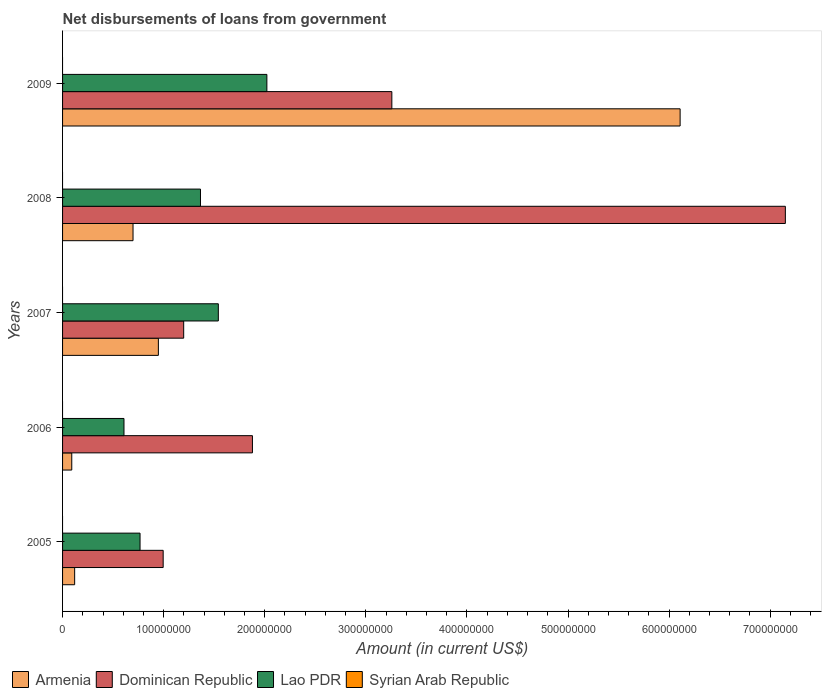How many different coloured bars are there?
Provide a short and direct response. 3. Are the number of bars per tick equal to the number of legend labels?
Provide a succinct answer. No. Are the number of bars on each tick of the Y-axis equal?
Make the answer very short. Yes. How many bars are there on the 3rd tick from the top?
Your answer should be compact. 3. What is the amount of loan disbursed from government in Armenia in 2006?
Offer a very short reply. 9.10e+06. Across all years, what is the maximum amount of loan disbursed from government in Dominican Republic?
Provide a succinct answer. 7.15e+08. Across all years, what is the minimum amount of loan disbursed from government in Dominican Republic?
Offer a terse response. 9.95e+07. What is the total amount of loan disbursed from government in Armenia in the graph?
Your response must be concise. 7.96e+08. What is the difference between the amount of loan disbursed from government in Lao PDR in 2006 and that in 2009?
Keep it short and to the point. -1.41e+08. What is the difference between the amount of loan disbursed from government in Dominican Republic in 2006 and the amount of loan disbursed from government in Syrian Arab Republic in 2008?
Provide a short and direct response. 1.88e+08. What is the average amount of loan disbursed from government in Armenia per year?
Give a very brief answer. 1.59e+08. In the year 2008, what is the difference between the amount of loan disbursed from government in Lao PDR and amount of loan disbursed from government in Armenia?
Your answer should be very brief. 6.67e+07. What is the ratio of the amount of loan disbursed from government in Lao PDR in 2006 to that in 2009?
Offer a terse response. 0.3. Is the amount of loan disbursed from government in Lao PDR in 2007 less than that in 2008?
Ensure brevity in your answer.  No. What is the difference between the highest and the second highest amount of loan disbursed from government in Dominican Republic?
Offer a very short reply. 3.89e+08. What is the difference between the highest and the lowest amount of loan disbursed from government in Dominican Republic?
Offer a very short reply. 6.15e+08. Is it the case that in every year, the sum of the amount of loan disbursed from government in Armenia and amount of loan disbursed from government in Syrian Arab Republic is greater than the sum of amount of loan disbursed from government in Lao PDR and amount of loan disbursed from government in Dominican Republic?
Your answer should be compact. No. How many bars are there?
Your answer should be compact. 15. How many years are there in the graph?
Make the answer very short. 5. Does the graph contain any zero values?
Provide a short and direct response. Yes. Does the graph contain grids?
Your answer should be compact. No. How are the legend labels stacked?
Your answer should be very brief. Horizontal. What is the title of the graph?
Offer a terse response. Net disbursements of loans from government. Does "Middle East & North Africa (all income levels)" appear as one of the legend labels in the graph?
Your response must be concise. No. What is the label or title of the Y-axis?
Ensure brevity in your answer.  Years. What is the Amount (in current US$) in Armenia in 2005?
Your answer should be very brief. 1.20e+07. What is the Amount (in current US$) of Dominican Republic in 2005?
Make the answer very short. 9.95e+07. What is the Amount (in current US$) of Lao PDR in 2005?
Provide a short and direct response. 7.66e+07. What is the Amount (in current US$) of Syrian Arab Republic in 2005?
Offer a very short reply. 0. What is the Amount (in current US$) of Armenia in 2006?
Offer a terse response. 9.10e+06. What is the Amount (in current US$) in Dominican Republic in 2006?
Your answer should be very brief. 1.88e+08. What is the Amount (in current US$) in Lao PDR in 2006?
Provide a short and direct response. 6.08e+07. What is the Amount (in current US$) of Armenia in 2007?
Your answer should be very brief. 9.48e+07. What is the Amount (in current US$) in Dominican Republic in 2007?
Keep it short and to the point. 1.20e+08. What is the Amount (in current US$) of Lao PDR in 2007?
Your answer should be very brief. 1.54e+08. What is the Amount (in current US$) of Armenia in 2008?
Offer a very short reply. 6.97e+07. What is the Amount (in current US$) of Dominican Republic in 2008?
Offer a terse response. 7.15e+08. What is the Amount (in current US$) of Lao PDR in 2008?
Offer a very short reply. 1.36e+08. What is the Amount (in current US$) in Armenia in 2009?
Offer a terse response. 6.11e+08. What is the Amount (in current US$) of Dominican Republic in 2009?
Keep it short and to the point. 3.26e+08. What is the Amount (in current US$) of Lao PDR in 2009?
Keep it short and to the point. 2.02e+08. Across all years, what is the maximum Amount (in current US$) of Armenia?
Provide a short and direct response. 6.11e+08. Across all years, what is the maximum Amount (in current US$) of Dominican Republic?
Make the answer very short. 7.15e+08. Across all years, what is the maximum Amount (in current US$) in Lao PDR?
Provide a succinct answer. 2.02e+08. Across all years, what is the minimum Amount (in current US$) in Armenia?
Your response must be concise. 9.10e+06. Across all years, what is the minimum Amount (in current US$) in Dominican Republic?
Provide a short and direct response. 9.95e+07. Across all years, what is the minimum Amount (in current US$) in Lao PDR?
Your answer should be compact. 6.08e+07. What is the total Amount (in current US$) of Armenia in the graph?
Offer a very short reply. 7.96e+08. What is the total Amount (in current US$) of Dominican Republic in the graph?
Make the answer very short. 1.45e+09. What is the total Amount (in current US$) of Lao PDR in the graph?
Offer a terse response. 6.30e+08. What is the difference between the Amount (in current US$) of Armenia in 2005 and that in 2006?
Your response must be concise. 2.87e+06. What is the difference between the Amount (in current US$) of Dominican Republic in 2005 and that in 2006?
Your answer should be very brief. -8.83e+07. What is the difference between the Amount (in current US$) of Lao PDR in 2005 and that in 2006?
Offer a very short reply. 1.59e+07. What is the difference between the Amount (in current US$) in Armenia in 2005 and that in 2007?
Provide a short and direct response. -8.28e+07. What is the difference between the Amount (in current US$) of Dominican Republic in 2005 and that in 2007?
Give a very brief answer. -2.03e+07. What is the difference between the Amount (in current US$) of Lao PDR in 2005 and that in 2007?
Your answer should be very brief. -7.74e+07. What is the difference between the Amount (in current US$) in Armenia in 2005 and that in 2008?
Offer a terse response. -5.77e+07. What is the difference between the Amount (in current US$) of Dominican Republic in 2005 and that in 2008?
Provide a succinct answer. -6.15e+08. What is the difference between the Amount (in current US$) in Lao PDR in 2005 and that in 2008?
Your answer should be very brief. -5.98e+07. What is the difference between the Amount (in current US$) in Armenia in 2005 and that in 2009?
Provide a succinct answer. -5.99e+08. What is the difference between the Amount (in current US$) of Dominican Republic in 2005 and that in 2009?
Your answer should be very brief. -2.26e+08. What is the difference between the Amount (in current US$) in Lao PDR in 2005 and that in 2009?
Offer a terse response. -1.25e+08. What is the difference between the Amount (in current US$) of Armenia in 2006 and that in 2007?
Provide a succinct answer. -8.57e+07. What is the difference between the Amount (in current US$) in Dominican Republic in 2006 and that in 2007?
Provide a succinct answer. 6.80e+07. What is the difference between the Amount (in current US$) in Lao PDR in 2006 and that in 2007?
Offer a terse response. -9.33e+07. What is the difference between the Amount (in current US$) in Armenia in 2006 and that in 2008?
Provide a short and direct response. -6.06e+07. What is the difference between the Amount (in current US$) in Dominican Republic in 2006 and that in 2008?
Your answer should be very brief. -5.27e+08. What is the difference between the Amount (in current US$) in Lao PDR in 2006 and that in 2008?
Keep it short and to the point. -7.57e+07. What is the difference between the Amount (in current US$) in Armenia in 2006 and that in 2009?
Your answer should be very brief. -6.02e+08. What is the difference between the Amount (in current US$) of Dominican Republic in 2006 and that in 2009?
Give a very brief answer. -1.38e+08. What is the difference between the Amount (in current US$) of Lao PDR in 2006 and that in 2009?
Your answer should be compact. -1.41e+08. What is the difference between the Amount (in current US$) in Armenia in 2007 and that in 2008?
Provide a succinct answer. 2.51e+07. What is the difference between the Amount (in current US$) in Dominican Republic in 2007 and that in 2008?
Your answer should be very brief. -5.95e+08. What is the difference between the Amount (in current US$) in Lao PDR in 2007 and that in 2008?
Provide a succinct answer. 1.76e+07. What is the difference between the Amount (in current US$) in Armenia in 2007 and that in 2009?
Your answer should be compact. -5.16e+08. What is the difference between the Amount (in current US$) of Dominican Republic in 2007 and that in 2009?
Your answer should be compact. -2.06e+08. What is the difference between the Amount (in current US$) of Lao PDR in 2007 and that in 2009?
Your response must be concise. -4.80e+07. What is the difference between the Amount (in current US$) in Armenia in 2008 and that in 2009?
Your response must be concise. -5.41e+08. What is the difference between the Amount (in current US$) in Dominican Republic in 2008 and that in 2009?
Your answer should be compact. 3.89e+08. What is the difference between the Amount (in current US$) in Lao PDR in 2008 and that in 2009?
Ensure brevity in your answer.  -6.57e+07. What is the difference between the Amount (in current US$) in Armenia in 2005 and the Amount (in current US$) in Dominican Republic in 2006?
Make the answer very short. -1.76e+08. What is the difference between the Amount (in current US$) in Armenia in 2005 and the Amount (in current US$) in Lao PDR in 2006?
Give a very brief answer. -4.88e+07. What is the difference between the Amount (in current US$) in Dominican Republic in 2005 and the Amount (in current US$) in Lao PDR in 2006?
Your answer should be very brief. 3.88e+07. What is the difference between the Amount (in current US$) of Armenia in 2005 and the Amount (in current US$) of Dominican Republic in 2007?
Offer a terse response. -1.08e+08. What is the difference between the Amount (in current US$) in Armenia in 2005 and the Amount (in current US$) in Lao PDR in 2007?
Offer a very short reply. -1.42e+08. What is the difference between the Amount (in current US$) of Dominican Republic in 2005 and the Amount (in current US$) of Lao PDR in 2007?
Your answer should be compact. -5.46e+07. What is the difference between the Amount (in current US$) of Armenia in 2005 and the Amount (in current US$) of Dominican Republic in 2008?
Offer a very short reply. -7.03e+08. What is the difference between the Amount (in current US$) of Armenia in 2005 and the Amount (in current US$) of Lao PDR in 2008?
Your answer should be compact. -1.24e+08. What is the difference between the Amount (in current US$) in Dominican Republic in 2005 and the Amount (in current US$) in Lao PDR in 2008?
Make the answer very short. -3.69e+07. What is the difference between the Amount (in current US$) in Armenia in 2005 and the Amount (in current US$) in Dominican Republic in 2009?
Ensure brevity in your answer.  -3.14e+08. What is the difference between the Amount (in current US$) in Armenia in 2005 and the Amount (in current US$) in Lao PDR in 2009?
Keep it short and to the point. -1.90e+08. What is the difference between the Amount (in current US$) of Dominican Republic in 2005 and the Amount (in current US$) of Lao PDR in 2009?
Make the answer very short. -1.03e+08. What is the difference between the Amount (in current US$) in Armenia in 2006 and the Amount (in current US$) in Dominican Republic in 2007?
Keep it short and to the point. -1.11e+08. What is the difference between the Amount (in current US$) in Armenia in 2006 and the Amount (in current US$) in Lao PDR in 2007?
Your answer should be very brief. -1.45e+08. What is the difference between the Amount (in current US$) in Dominican Republic in 2006 and the Amount (in current US$) in Lao PDR in 2007?
Ensure brevity in your answer.  3.37e+07. What is the difference between the Amount (in current US$) of Armenia in 2006 and the Amount (in current US$) of Dominican Republic in 2008?
Your answer should be compact. -7.06e+08. What is the difference between the Amount (in current US$) in Armenia in 2006 and the Amount (in current US$) in Lao PDR in 2008?
Provide a succinct answer. -1.27e+08. What is the difference between the Amount (in current US$) in Dominican Republic in 2006 and the Amount (in current US$) in Lao PDR in 2008?
Give a very brief answer. 5.14e+07. What is the difference between the Amount (in current US$) of Armenia in 2006 and the Amount (in current US$) of Dominican Republic in 2009?
Your answer should be compact. -3.17e+08. What is the difference between the Amount (in current US$) in Armenia in 2006 and the Amount (in current US$) in Lao PDR in 2009?
Offer a very short reply. -1.93e+08. What is the difference between the Amount (in current US$) in Dominican Republic in 2006 and the Amount (in current US$) in Lao PDR in 2009?
Provide a short and direct response. -1.43e+07. What is the difference between the Amount (in current US$) of Armenia in 2007 and the Amount (in current US$) of Dominican Republic in 2008?
Your answer should be very brief. -6.20e+08. What is the difference between the Amount (in current US$) of Armenia in 2007 and the Amount (in current US$) of Lao PDR in 2008?
Offer a very short reply. -4.16e+07. What is the difference between the Amount (in current US$) in Dominican Republic in 2007 and the Amount (in current US$) in Lao PDR in 2008?
Offer a terse response. -1.66e+07. What is the difference between the Amount (in current US$) in Armenia in 2007 and the Amount (in current US$) in Dominican Republic in 2009?
Offer a terse response. -2.31e+08. What is the difference between the Amount (in current US$) in Armenia in 2007 and the Amount (in current US$) in Lao PDR in 2009?
Your response must be concise. -1.07e+08. What is the difference between the Amount (in current US$) in Dominican Republic in 2007 and the Amount (in current US$) in Lao PDR in 2009?
Offer a terse response. -8.23e+07. What is the difference between the Amount (in current US$) in Armenia in 2008 and the Amount (in current US$) in Dominican Republic in 2009?
Offer a terse response. -2.56e+08. What is the difference between the Amount (in current US$) in Armenia in 2008 and the Amount (in current US$) in Lao PDR in 2009?
Your response must be concise. -1.32e+08. What is the difference between the Amount (in current US$) in Dominican Republic in 2008 and the Amount (in current US$) in Lao PDR in 2009?
Your answer should be compact. 5.13e+08. What is the average Amount (in current US$) in Armenia per year?
Ensure brevity in your answer.  1.59e+08. What is the average Amount (in current US$) in Dominican Republic per year?
Offer a very short reply. 2.90e+08. What is the average Amount (in current US$) in Lao PDR per year?
Give a very brief answer. 1.26e+08. In the year 2005, what is the difference between the Amount (in current US$) in Armenia and Amount (in current US$) in Dominican Republic?
Your answer should be compact. -8.76e+07. In the year 2005, what is the difference between the Amount (in current US$) in Armenia and Amount (in current US$) in Lao PDR?
Ensure brevity in your answer.  -6.47e+07. In the year 2005, what is the difference between the Amount (in current US$) in Dominican Republic and Amount (in current US$) in Lao PDR?
Ensure brevity in your answer.  2.29e+07. In the year 2006, what is the difference between the Amount (in current US$) in Armenia and Amount (in current US$) in Dominican Republic?
Provide a succinct answer. -1.79e+08. In the year 2006, what is the difference between the Amount (in current US$) in Armenia and Amount (in current US$) in Lao PDR?
Your response must be concise. -5.17e+07. In the year 2006, what is the difference between the Amount (in current US$) of Dominican Republic and Amount (in current US$) of Lao PDR?
Your answer should be compact. 1.27e+08. In the year 2007, what is the difference between the Amount (in current US$) of Armenia and Amount (in current US$) of Dominican Republic?
Provide a short and direct response. -2.50e+07. In the year 2007, what is the difference between the Amount (in current US$) of Armenia and Amount (in current US$) of Lao PDR?
Provide a short and direct response. -5.93e+07. In the year 2007, what is the difference between the Amount (in current US$) in Dominican Republic and Amount (in current US$) in Lao PDR?
Make the answer very short. -3.43e+07. In the year 2008, what is the difference between the Amount (in current US$) in Armenia and Amount (in current US$) in Dominican Republic?
Your answer should be very brief. -6.45e+08. In the year 2008, what is the difference between the Amount (in current US$) of Armenia and Amount (in current US$) of Lao PDR?
Your response must be concise. -6.67e+07. In the year 2008, what is the difference between the Amount (in current US$) of Dominican Republic and Amount (in current US$) of Lao PDR?
Your answer should be compact. 5.79e+08. In the year 2009, what is the difference between the Amount (in current US$) of Armenia and Amount (in current US$) of Dominican Republic?
Offer a very short reply. 2.85e+08. In the year 2009, what is the difference between the Amount (in current US$) of Armenia and Amount (in current US$) of Lao PDR?
Your response must be concise. 4.09e+08. In the year 2009, what is the difference between the Amount (in current US$) of Dominican Republic and Amount (in current US$) of Lao PDR?
Keep it short and to the point. 1.24e+08. What is the ratio of the Amount (in current US$) in Armenia in 2005 to that in 2006?
Ensure brevity in your answer.  1.32. What is the ratio of the Amount (in current US$) in Dominican Republic in 2005 to that in 2006?
Your answer should be compact. 0.53. What is the ratio of the Amount (in current US$) in Lao PDR in 2005 to that in 2006?
Ensure brevity in your answer.  1.26. What is the ratio of the Amount (in current US$) in Armenia in 2005 to that in 2007?
Offer a terse response. 0.13. What is the ratio of the Amount (in current US$) in Dominican Republic in 2005 to that in 2007?
Provide a short and direct response. 0.83. What is the ratio of the Amount (in current US$) of Lao PDR in 2005 to that in 2007?
Ensure brevity in your answer.  0.5. What is the ratio of the Amount (in current US$) of Armenia in 2005 to that in 2008?
Your response must be concise. 0.17. What is the ratio of the Amount (in current US$) in Dominican Republic in 2005 to that in 2008?
Your answer should be very brief. 0.14. What is the ratio of the Amount (in current US$) in Lao PDR in 2005 to that in 2008?
Your answer should be very brief. 0.56. What is the ratio of the Amount (in current US$) in Armenia in 2005 to that in 2009?
Make the answer very short. 0.02. What is the ratio of the Amount (in current US$) of Dominican Republic in 2005 to that in 2009?
Offer a terse response. 0.31. What is the ratio of the Amount (in current US$) of Lao PDR in 2005 to that in 2009?
Your response must be concise. 0.38. What is the ratio of the Amount (in current US$) in Armenia in 2006 to that in 2007?
Provide a short and direct response. 0.1. What is the ratio of the Amount (in current US$) in Dominican Republic in 2006 to that in 2007?
Your answer should be compact. 1.57. What is the ratio of the Amount (in current US$) of Lao PDR in 2006 to that in 2007?
Make the answer very short. 0.39. What is the ratio of the Amount (in current US$) of Armenia in 2006 to that in 2008?
Your answer should be compact. 0.13. What is the ratio of the Amount (in current US$) in Dominican Republic in 2006 to that in 2008?
Give a very brief answer. 0.26. What is the ratio of the Amount (in current US$) in Lao PDR in 2006 to that in 2008?
Give a very brief answer. 0.45. What is the ratio of the Amount (in current US$) in Armenia in 2006 to that in 2009?
Your response must be concise. 0.01. What is the ratio of the Amount (in current US$) in Dominican Republic in 2006 to that in 2009?
Your answer should be very brief. 0.58. What is the ratio of the Amount (in current US$) in Lao PDR in 2006 to that in 2009?
Ensure brevity in your answer.  0.3. What is the ratio of the Amount (in current US$) of Armenia in 2007 to that in 2008?
Provide a short and direct response. 1.36. What is the ratio of the Amount (in current US$) in Dominican Republic in 2007 to that in 2008?
Your response must be concise. 0.17. What is the ratio of the Amount (in current US$) in Lao PDR in 2007 to that in 2008?
Your response must be concise. 1.13. What is the ratio of the Amount (in current US$) in Armenia in 2007 to that in 2009?
Give a very brief answer. 0.16. What is the ratio of the Amount (in current US$) of Dominican Republic in 2007 to that in 2009?
Provide a succinct answer. 0.37. What is the ratio of the Amount (in current US$) of Lao PDR in 2007 to that in 2009?
Your answer should be very brief. 0.76. What is the ratio of the Amount (in current US$) in Armenia in 2008 to that in 2009?
Your response must be concise. 0.11. What is the ratio of the Amount (in current US$) of Dominican Republic in 2008 to that in 2009?
Your answer should be compact. 2.2. What is the ratio of the Amount (in current US$) of Lao PDR in 2008 to that in 2009?
Provide a succinct answer. 0.68. What is the difference between the highest and the second highest Amount (in current US$) in Armenia?
Make the answer very short. 5.16e+08. What is the difference between the highest and the second highest Amount (in current US$) in Dominican Republic?
Provide a succinct answer. 3.89e+08. What is the difference between the highest and the second highest Amount (in current US$) of Lao PDR?
Your response must be concise. 4.80e+07. What is the difference between the highest and the lowest Amount (in current US$) of Armenia?
Your response must be concise. 6.02e+08. What is the difference between the highest and the lowest Amount (in current US$) in Dominican Republic?
Your response must be concise. 6.15e+08. What is the difference between the highest and the lowest Amount (in current US$) in Lao PDR?
Your answer should be very brief. 1.41e+08. 